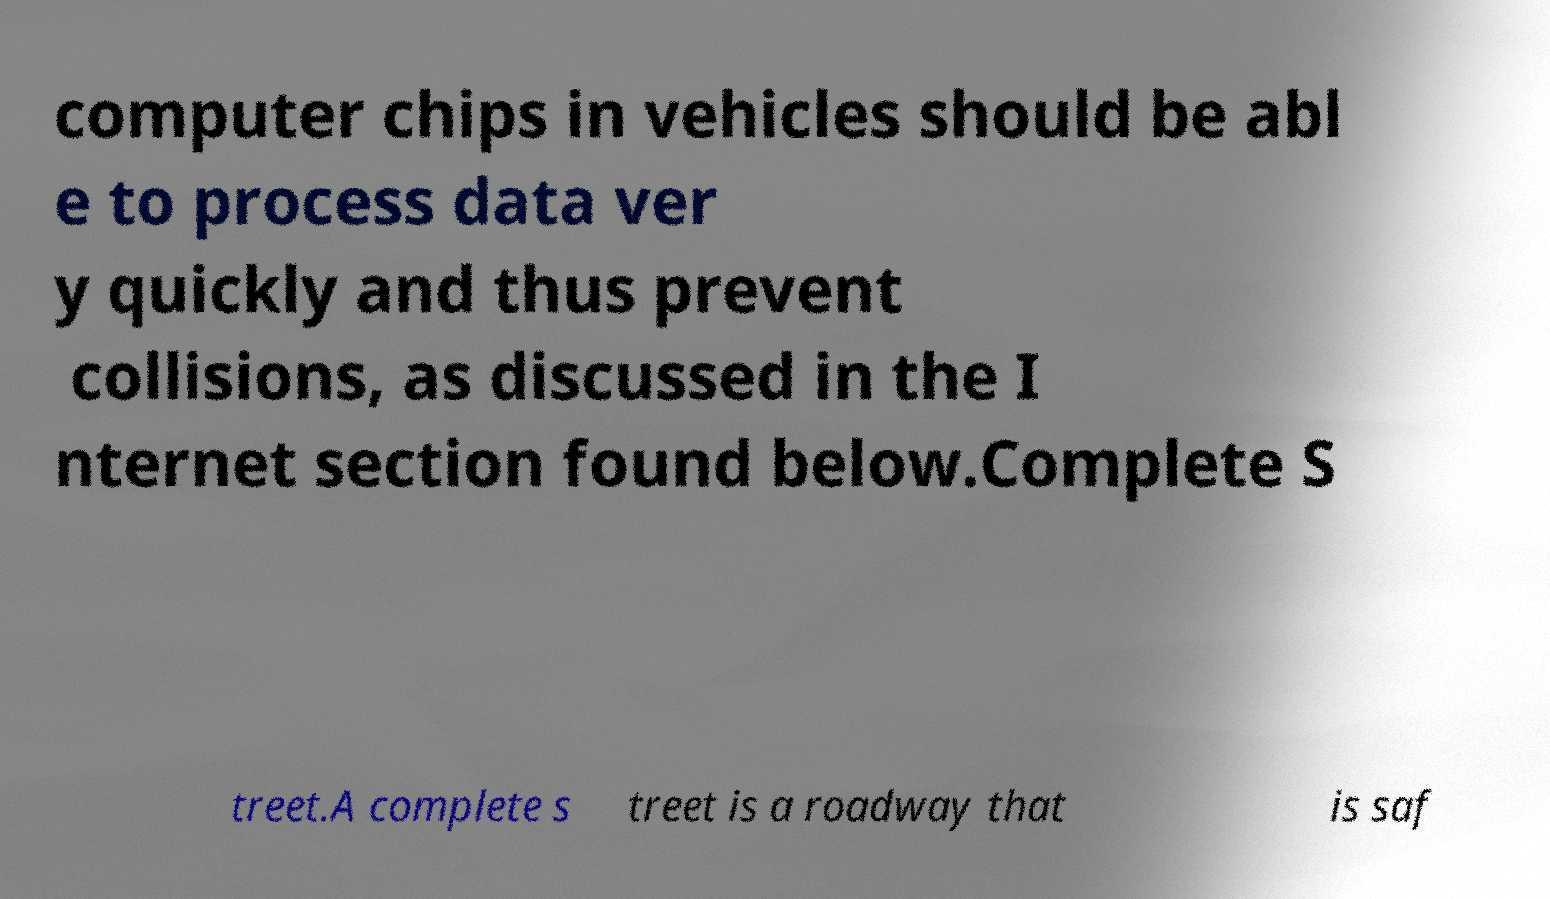Please read and relay the text visible in this image. What does it say? computer chips in vehicles should be abl e to process data ver y quickly and thus prevent collisions, as discussed in the I nternet section found below.Complete S treet.A complete s treet is a roadway that is saf 